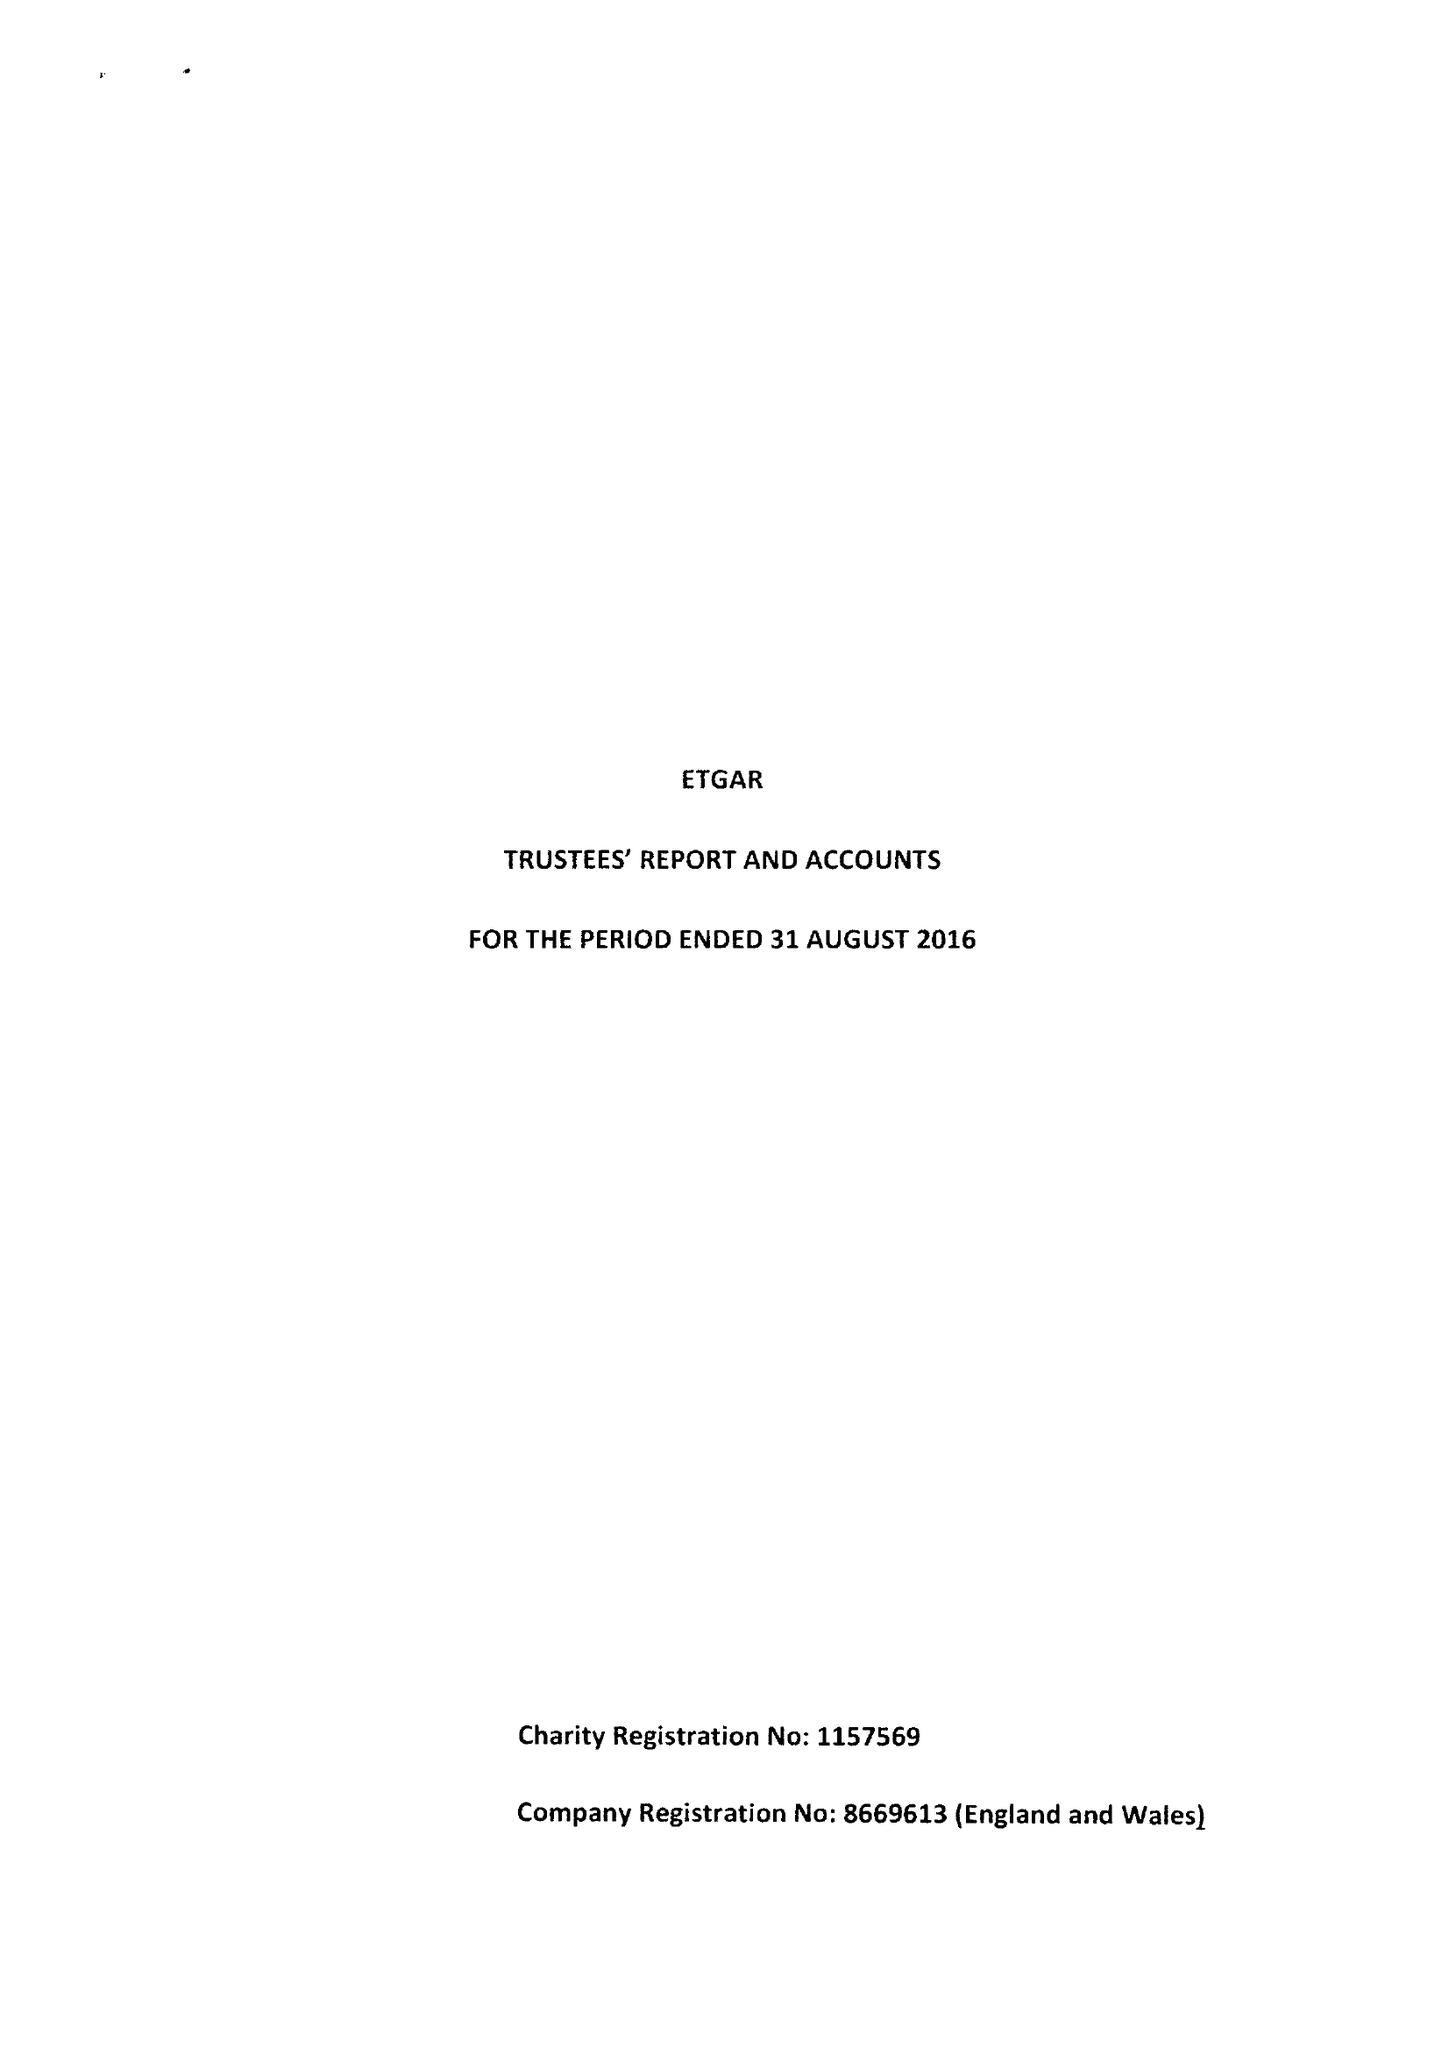What is the value for the income_annually_in_british_pounds?
Answer the question using a single word or phrase. 88410.00 